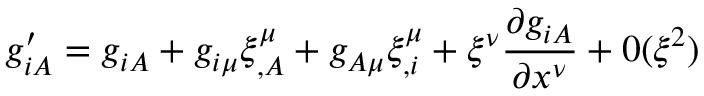<formula> <loc_0><loc_0><loc_500><loc_500>g _ { i A } ^ { \prime } = g _ { i A } + g _ { i \mu } \xi _ { , A } ^ { \mu } + g _ { A \mu } \xi _ { , i } ^ { \mu } + \xi ^ { \nu } \frac { \partial g _ { i A } } { \partial x ^ { \nu } } + 0 ( \xi ^ { 2 } )</formula> 